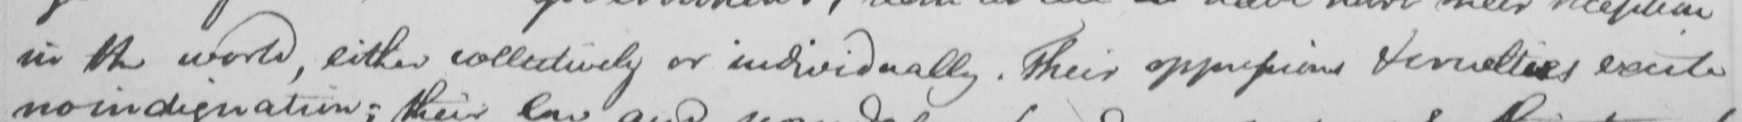Can you tell me what this handwritten text says? in the world , either collectively or individually . Their oppressions & cruelties excite 